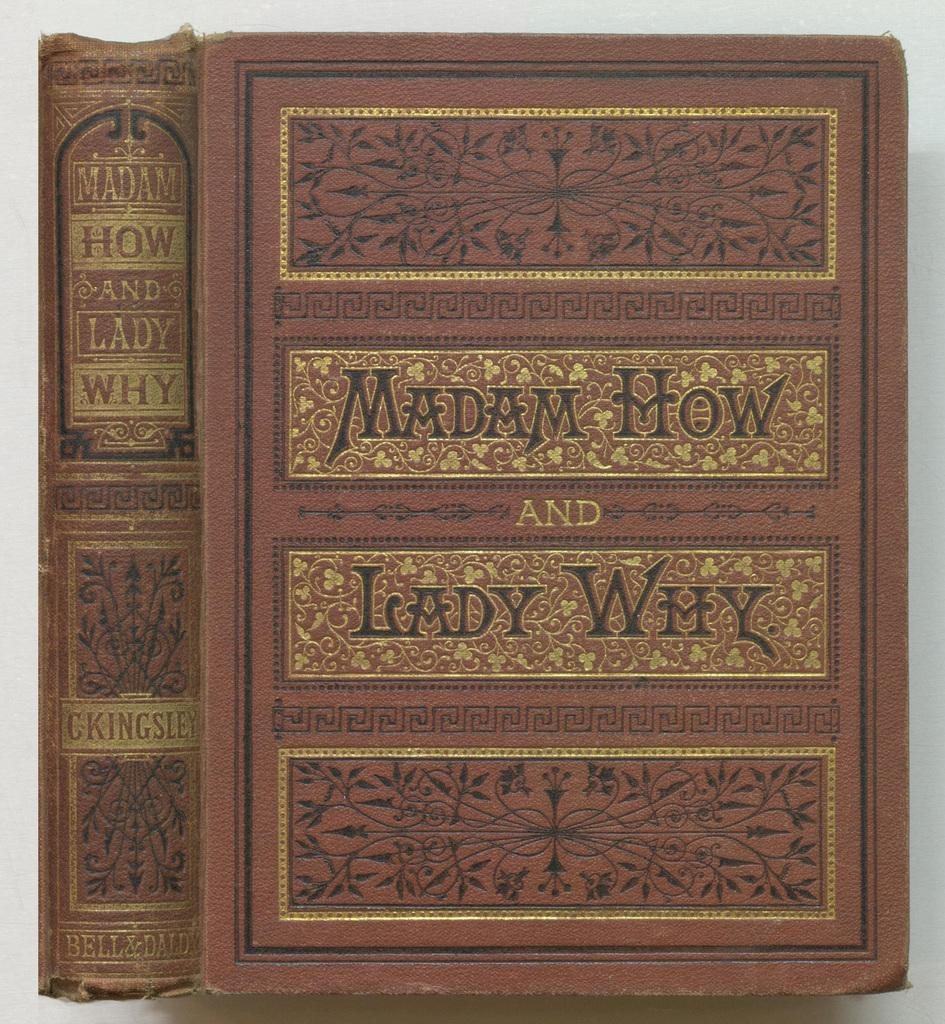<image>
Render a clear and concise summary of the photo. The title of the fancy book is Madam How and Lady Why. 